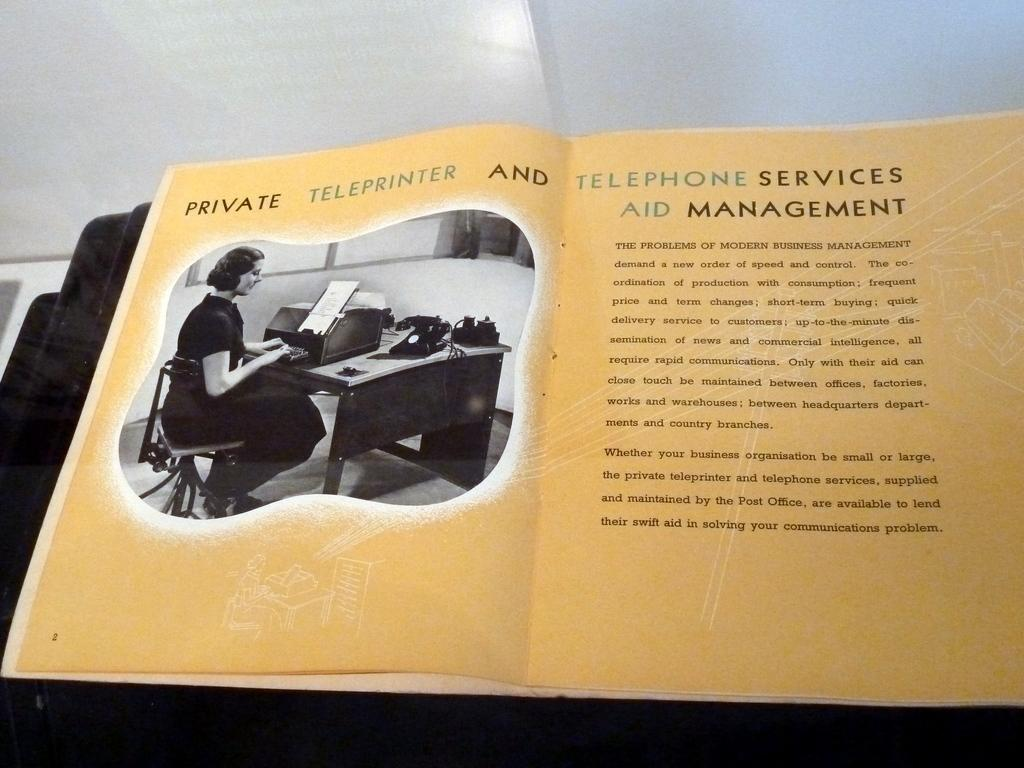<image>
Relay a brief, clear account of the picture shown. Open page showing a woman typing with the words "Private Teleprinter" on top. 